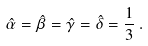<formula> <loc_0><loc_0><loc_500><loc_500>\hat { \alpha } = \hat { \beta } = \hat { \gamma } = \hat { \delta } = \frac { 1 } { 3 } \, .</formula> 